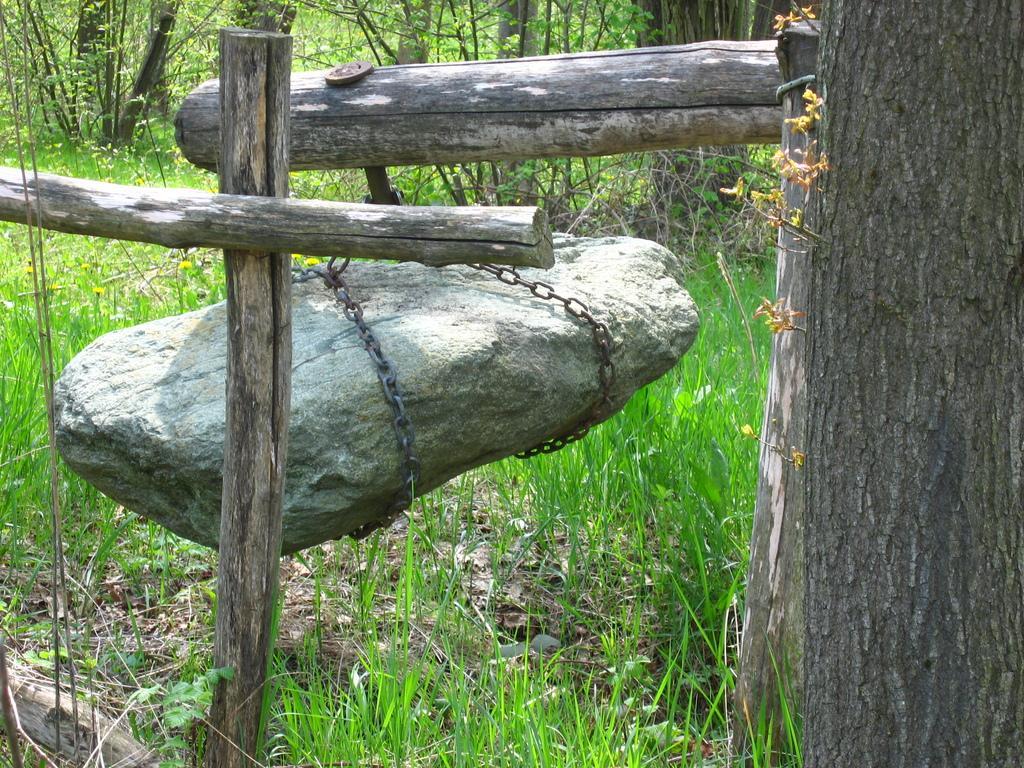Please provide a concise description of this image. In the image there are wooden poles. There is a stone hanging to the poles with the chains. On the right side of the image there is a tree trunk. In the background there are trees and on the ground there is grass. 